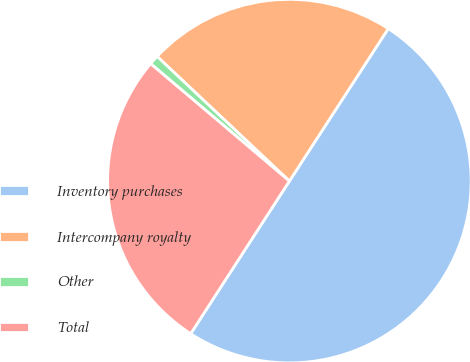Convert chart. <chart><loc_0><loc_0><loc_500><loc_500><pie_chart><fcel>Inventory purchases<fcel>Intercompany royalty<fcel>Other<fcel>Total<nl><fcel>49.98%<fcel>22.13%<fcel>0.85%<fcel>27.04%<nl></chart> 